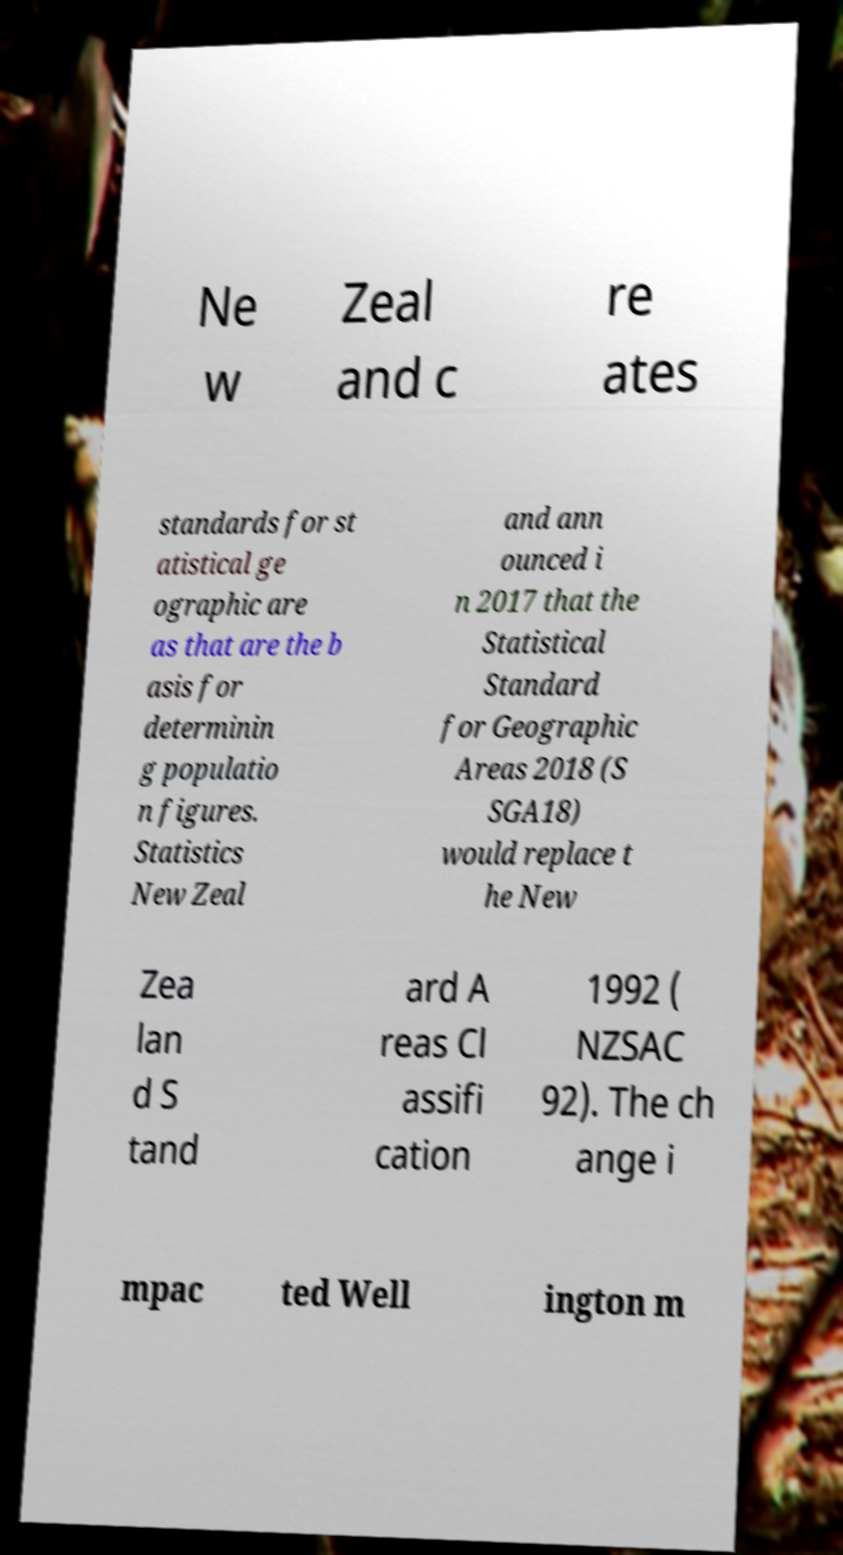There's text embedded in this image that I need extracted. Can you transcribe it verbatim? Ne w Zeal and c re ates standards for st atistical ge ographic are as that are the b asis for determinin g populatio n figures. Statistics New Zeal and ann ounced i n 2017 that the Statistical Standard for Geographic Areas 2018 (S SGA18) would replace t he New Zea lan d S tand ard A reas Cl assifi cation 1992 ( NZSAC 92). The ch ange i mpac ted Well ington m 